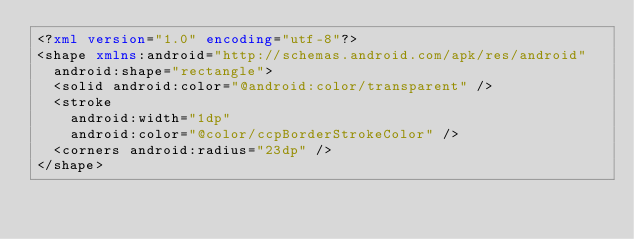Convert code to text. <code><loc_0><loc_0><loc_500><loc_500><_XML_><?xml version="1.0" encoding="utf-8"?>
<shape xmlns:android="http://schemas.android.com/apk/res/android"
  android:shape="rectangle">
  <solid android:color="@android:color/transparent" />
  <stroke
    android:width="1dp"
    android:color="@color/ccpBorderStrokeColor" />
  <corners android:radius="23dp" />
</shape></code> 